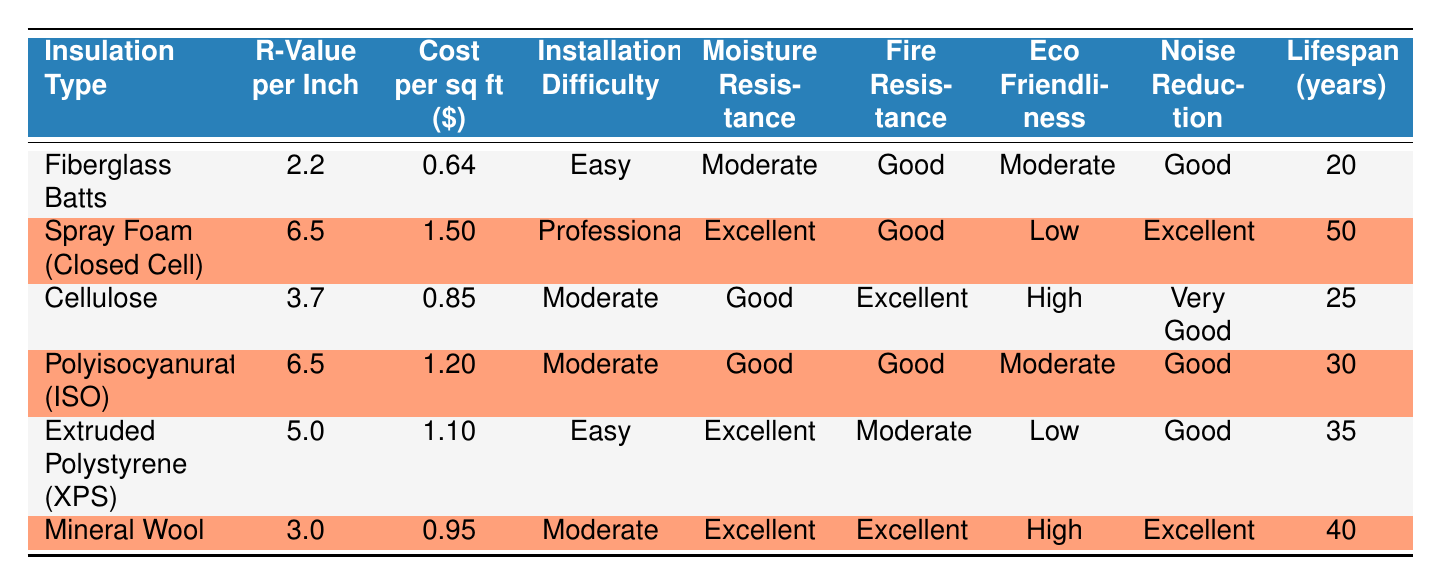What is the cost per square foot of Spray Foam (Closed Cell)? The table shows the specific cost per square foot under the column labeled "Cost per sq ft ($)". For Spray Foam (Closed Cell), it is listed as 1.50.
Answer: 1.50 Which insulation type has the best moisture resistance? The table lists the moisture resistance for each insulation type. Spray Foam (Closed Cell) and Extruded Polystyrene (XPS) have "Excellent" moisture resistance, which is the highest rating in the table.
Answer: Spray Foam (Closed Cell) and Extruded Polystyrene (XPS) What is the average lifespan of all the insulation types combined? To find the average lifespan, sum all the lifespans: (20 + 50 + 25 + 30 + 35 + 40) = 200. Then divide by 6 (the number of insulation types): 200 / 6 ≈ 33.33.
Answer: 33.33 Is the fire resistance of Cellulose better than that of Fiberglass Batts? The table indicates that Cellulose has an "Excellent" fire resistance while Fiberglass Batts has a "Good" fire resistance. Thus, Cellulose does indeed have better fire resistance.
Answer: Yes Which insulation type offers the lowest cost per square foot, and what is that cost? Compare the values in the "Cost per sq ft ($)" column and find the lowest one. Fiberglass Batts is listed at 0.64, which is the lowest among all the insulation types.
Answer: Fiberglass Batts, 0.64 How many insulation types have a lifespan greater than 30 years? Inspect the "Lifespan (years)" column for values greater than 30. The insulation types with lifespans over 30 years are Spray Foam (Closed Cell), Polyisocyanurate (ISO), Extruded Polystyrene (XPS), and Mineral Wool. This gives us a total of 4 types.
Answer: 4 Which insulation type has the highest R-value per inch and what is that value? The highest R-value per inch is found in both Spray Foam (Closed Cell) and Polyisocyanurate (ISO), each with a value of 6.5, as noted in the "R-Value per Inch" column.
Answer: 6.5 What is the total cost of 100 square feet of Extruded Polystyrene (XPS)? The cost per square foot of Extruded Polystyrene (XPS) is 1.10. Multiply this cost by 100 square feet to get the total: 1.10 * 100 = 110.
Answer: 110 Is it true that all insulation types have "Good" or better noise reduction ratings? By examining the "Noise Reduction" column, we see that all insulation types fall under "Good," "Very Good," or "Excellent." Therefore, the statement is true.
Answer: Yes 